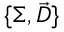<formula> <loc_0><loc_0><loc_500><loc_500>\{ \Sigma , \ V e c { D } \}</formula> 